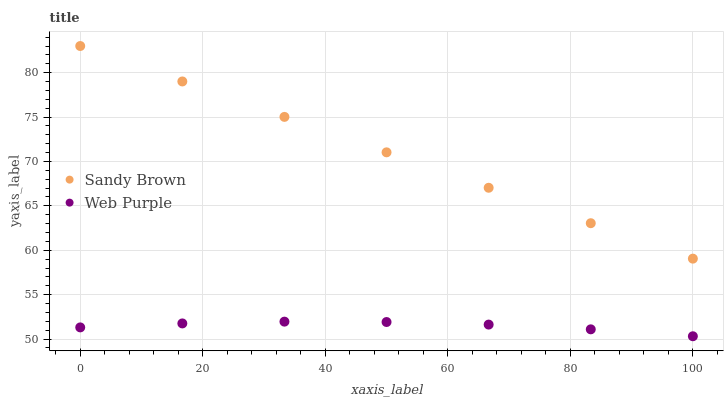Does Web Purple have the minimum area under the curve?
Answer yes or no. Yes. Does Sandy Brown have the maximum area under the curve?
Answer yes or no. Yes. Does Sandy Brown have the minimum area under the curve?
Answer yes or no. No. Is Sandy Brown the smoothest?
Answer yes or no. Yes. Is Web Purple the roughest?
Answer yes or no. Yes. Is Sandy Brown the roughest?
Answer yes or no. No. Does Web Purple have the lowest value?
Answer yes or no. Yes. Does Sandy Brown have the lowest value?
Answer yes or no. No. Does Sandy Brown have the highest value?
Answer yes or no. Yes. Is Web Purple less than Sandy Brown?
Answer yes or no. Yes. Is Sandy Brown greater than Web Purple?
Answer yes or no. Yes. Does Web Purple intersect Sandy Brown?
Answer yes or no. No. 